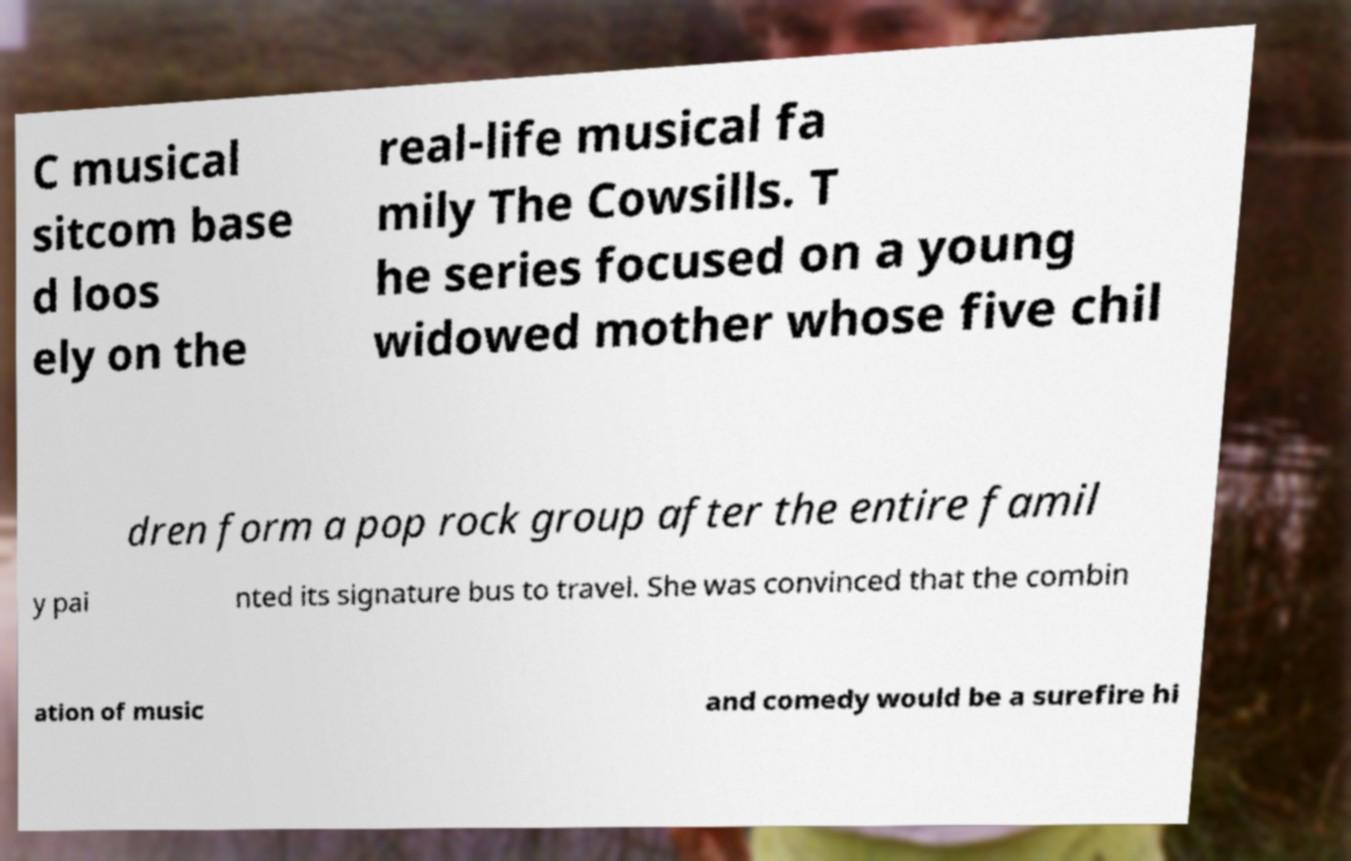I need the written content from this picture converted into text. Can you do that? C musical sitcom base d loos ely on the real-life musical fa mily The Cowsills. T he series focused on a young widowed mother whose five chil dren form a pop rock group after the entire famil y pai nted its signature bus to travel. She was convinced that the combin ation of music and comedy would be a surefire hi 